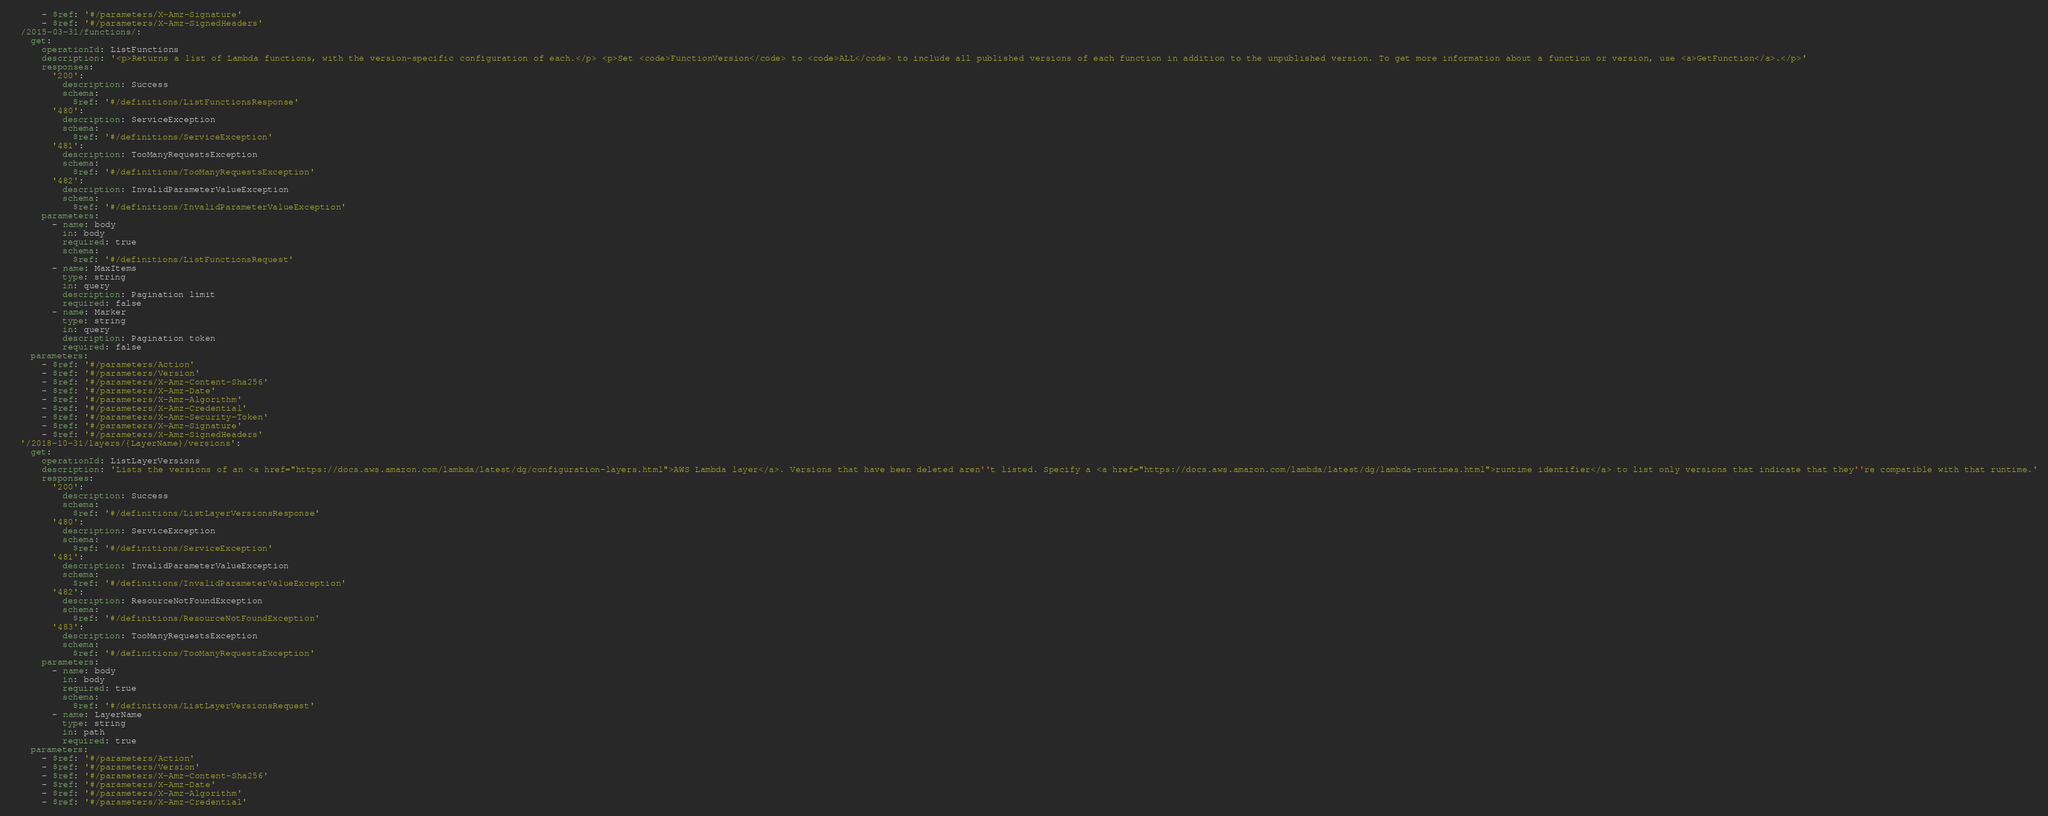Convert code to text. <code><loc_0><loc_0><loc_500><loc_500><_YAML_>      - $ref: '#/parameters/X-Amz-Signature'
      - $ref: '#/parameters/X-Amz-SignedHeaders'
  /2015-03-31/functions/:
    get:
      operationId: ListFunctions
      description: '<p>Returns a list of Lambda functions, with the version-specific configuration of each.</p> <p>Set <code>FunctionVersion</code> to <code>ALL</code> to include all published versions of each function in addition to the unpublished version. To get more information about a function or version, use <a>GetFunction</a>.</p>'
      responses:
        '200':
          description: Success
          schema:
            $ref: '#/definitions/ListFunctionsResponse'
        '480':
          description: ServiceException
          schema:
            $ref: '#/definitions/ServiceException'
        '481':
          description: TooManyRequestsException
          schema:
            $ref: '#/definitions/TooManyRequestsException'
        '482':
          description: InvalidParameterValueException
          schema:
            $ref: '#/definitions/InvalidParameterValueException'
      parameters:
        - name: body
          in: body
          required: true
          schema:
            $ref: '#/definitions/ListFunctionsRequest'
        - name: MaxItems
          type: string
          in: query
          description: Pagination limit
          required: false
        - name: Marker
          type: string
          in: query
          description: Pagination token
          required: false
    parameters:
      - $ref: '#/parameters/Action'
      - $ref: '#/parameters/Version'
      - $ref: '#/parameters/X-Amz-Content-Sha256'
      - $ref: '#/parameters/X-Amz-Date'
      - $ref: '#/parameters/X-Amz-Algorithm'
      - $ref: '#/parameters/X-Amz-Credential'
      - $ref: '#/parameters/X-Amz-Security-Token'
      - $ref: '#/parameters/X-Amz-Signature'
      - $ref: '#/parameters/X-Amz-SignedHeaders'
  '/2018-10-31/layers/{LayerName}/versions':
    get:
      operationId: ListLayerVersions
      description: 'Lists the versions of an <a href="https://docs.aws.amazon.com/lambda/latest/dg/configuration-layers.html">AWS Lambda layer</a>. Versions that have been deleted aren''t listed. Specify a <a href="https://docs.aws.amazon.com/lambda/latest/dg/lambda-runtimes.html">runtime identifier</a> to list only versions that indicate that they''re compatible with that runtime.'
      responses:
        '200':
          description: Success
          schema:
            $ref: '#/definitions/ListLayerVersionsResponse'
        '480':
          description: ServiceException
          schema:
            $ref: '#/definitions/ServiceException'
        '481':
          description: InvalidParameterValueException
          schema:
            $ref: '#/definitions/InvalidParameterValueException'
        '482':
          description: ResourceNotFoundException
          schema:
            $ref: '#/definitions/ResourceNotFoundException'
        '483':
          description: TooManyRequestsException
          schema:
            $ref: '#/definitions/TooManyRequestsException'
      parameters:
        - name: body
          in: body
          required: true
          schema:
            $ref: '#/definitions/ListLayerVersionsRequest'
        - name: LayerName
          type: string
          in: path
          required: true
    parameters:
      - $ref: '#/parameters/Action'
      - $ref: '#/parameters/Version'
      - $ref: '#/parameters/X-Amz-Content-Sha256'
      - $ref: '#/parameters/X-Amz-Date'
      - $ref: '#/parameters/X-Amz-Algorithm'
      - $ref: '#/parameters/X-Amz-Credential'</code> 